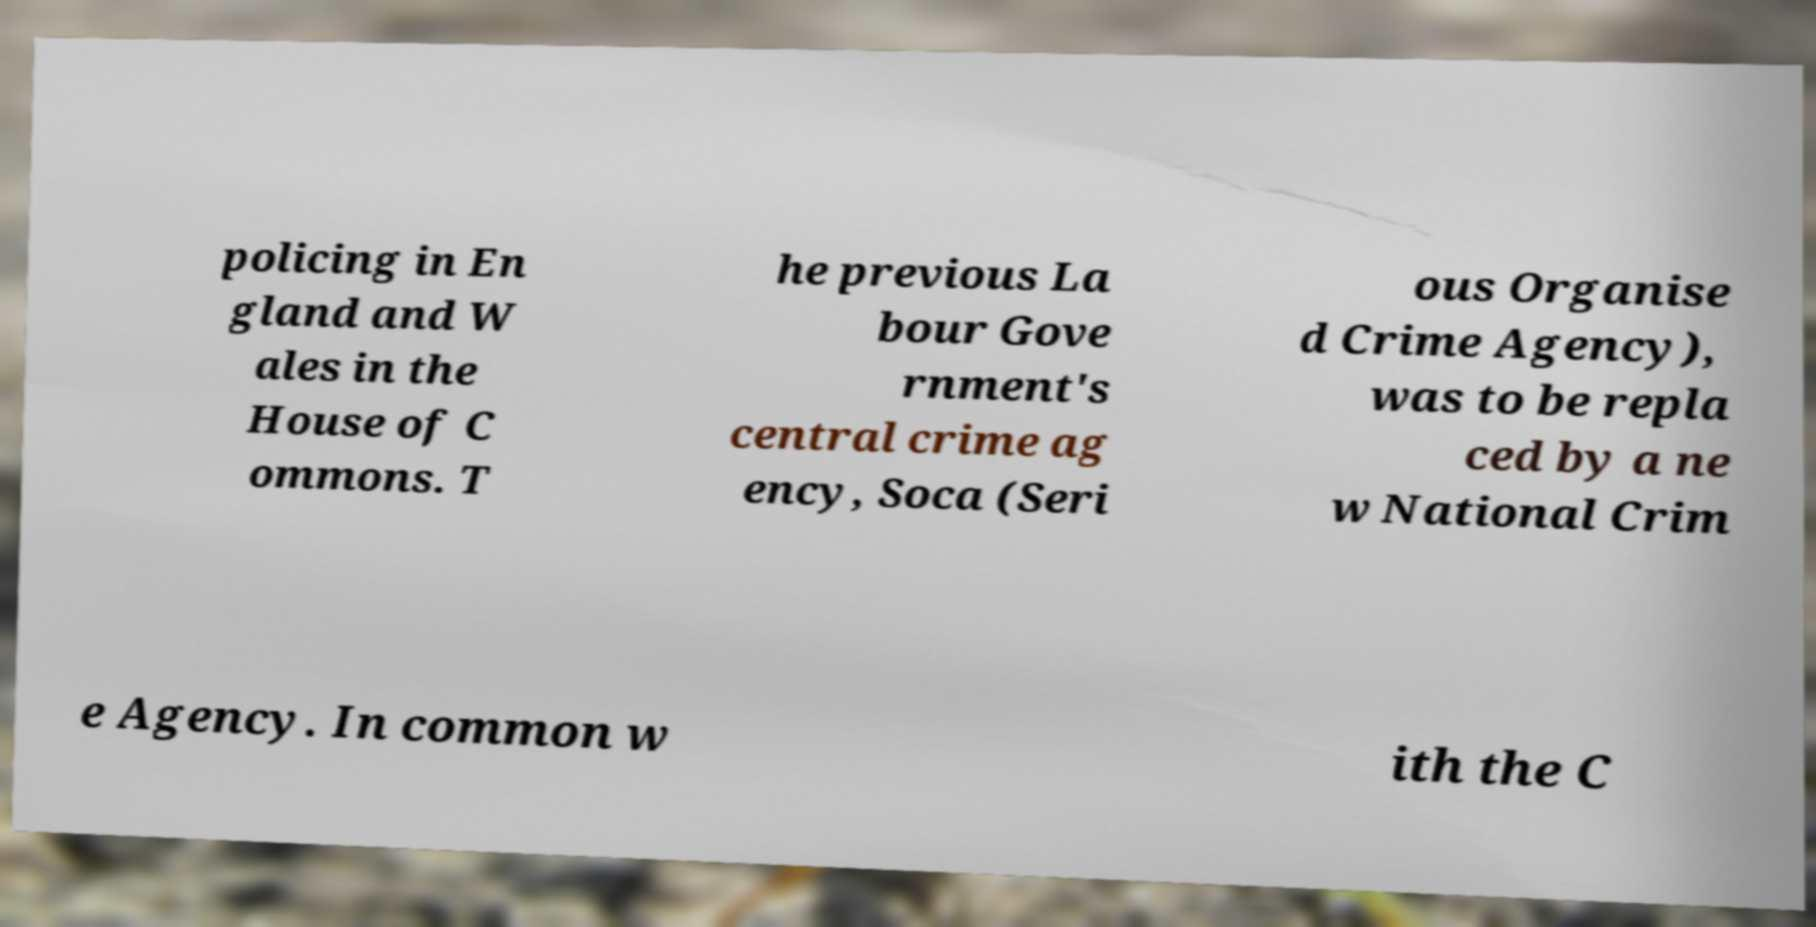What messages or text are displayed in this image? I need them in a readable, typed format. policing in En gland and W ales in the House of C ommons. T he previous La bour Gove rnment's central crime ag ency, Soca (Seri ous Organise d Crime Agency), was to be repla ced by a ne w National Crim e Agency. In common w ith the C 